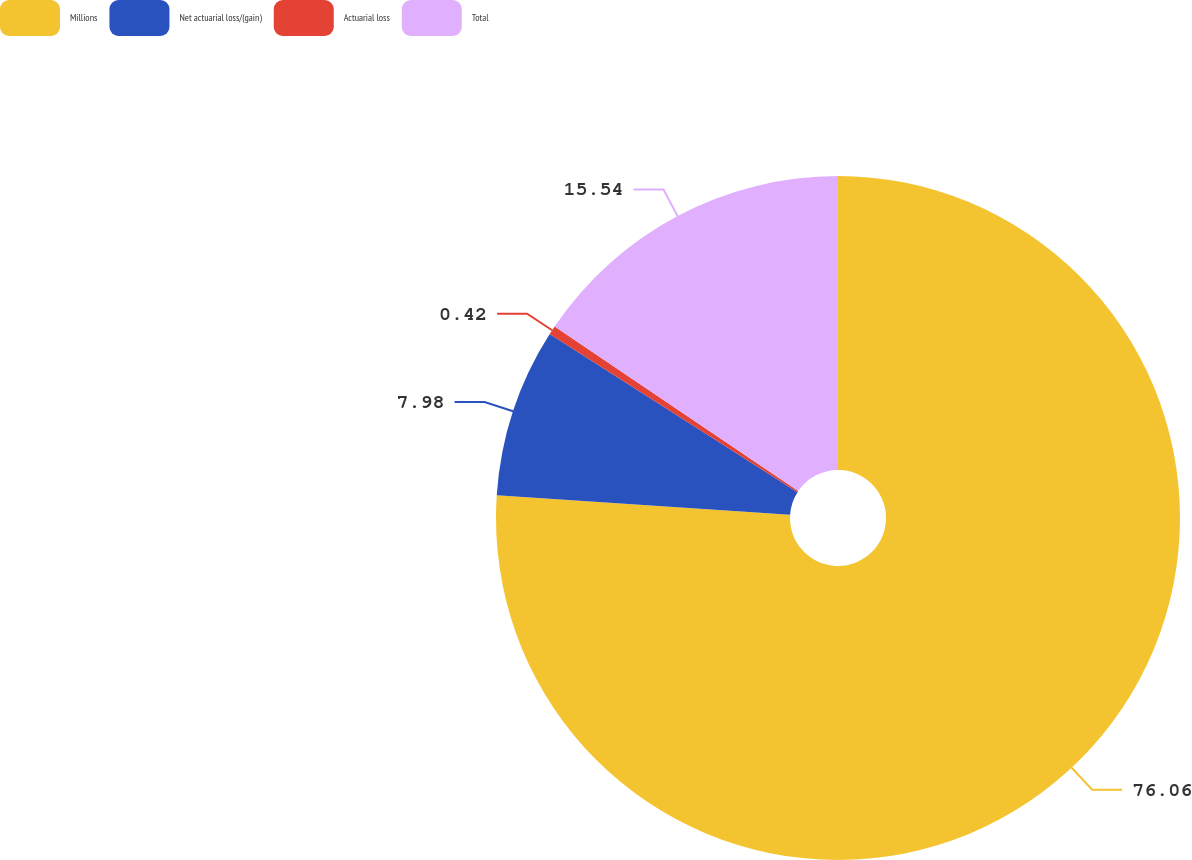Convert chart to OTSL. <chart><loc_0><loc_0><loc_500><loc_500><pie_chart><fcel>Millions<fcel>Net actuarial loss/(gain)<fcel>Actuarial loss<fcel>Total<nl><fcel>76.06%<fcel>7.98%<fcel>0.42%<fcel>15.54%<nl></chart> 